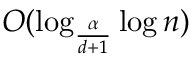Convert formula to latex. <formula><loc_0><loc_0><loc_500><loc_500>O ( \log _ { \frac { \alpha } { d + 1 } } \log n )</formula> 